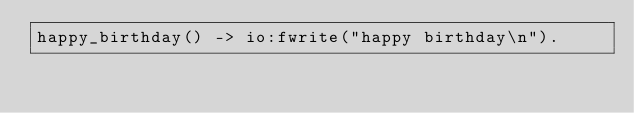<code> <loc_0><loc_0><loc_500><loc_500><_Erlang_>happy_birthday() -> io:fwrite("happy birthday\n").</code> 